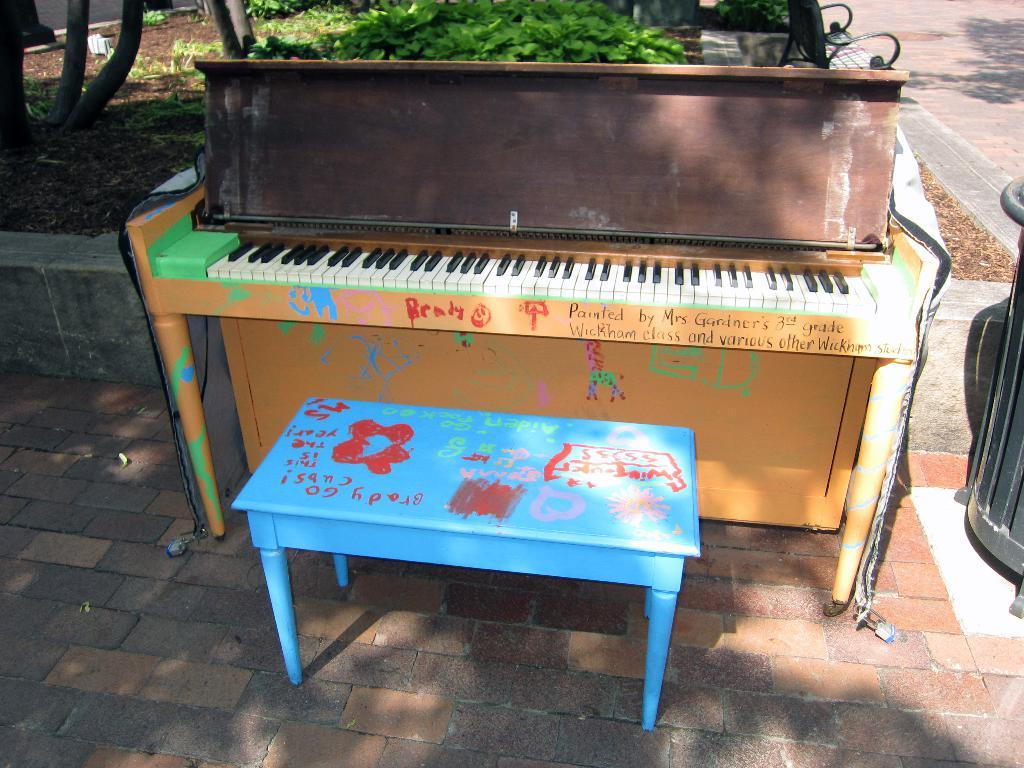What musical instrument is in the image? There is a piano in the image. What is placed in front of the piano? There is a chair in front of the piano. What can be seen in the background of the image? Plants and soil are present in the background of the image. What architectural feature is on the right side of the image? There is a walkway on the right side of the image. Where is the limit of the rice field in the image? There is no rice field present in the image. What type of meeting is taking place in the image? There is no meeting taking place in the image. 